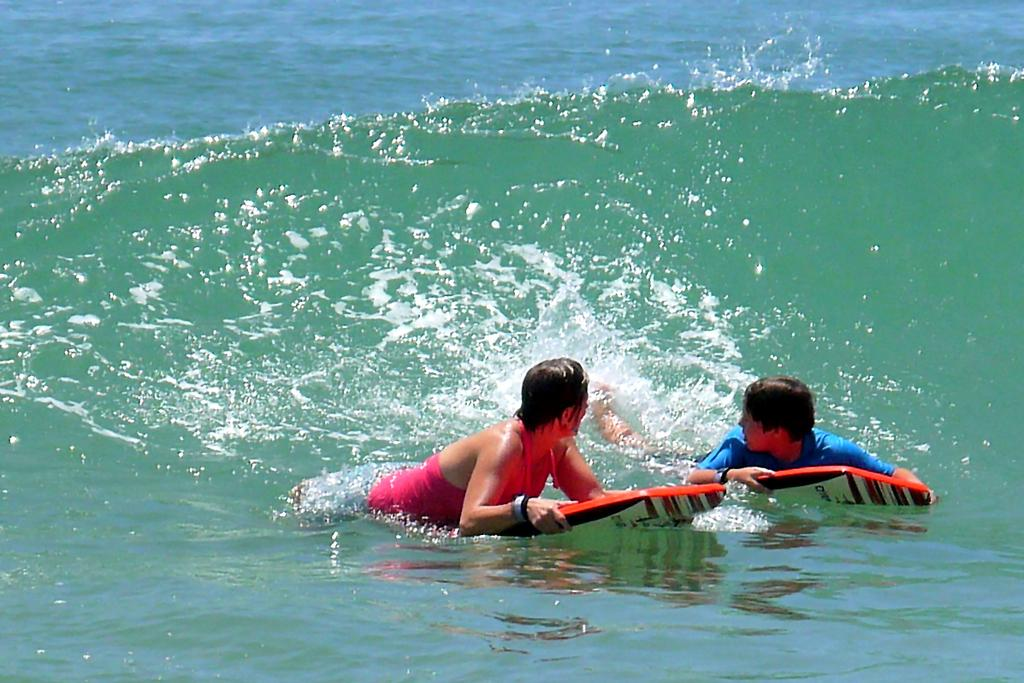How many people are in the image? There are two persons in the image. What are the persons doing in the image? The persons are on surfboards. What is the primary setting or environment in the image? There is water visible in the image. What type of silk fabric is being used by the persons in the image? There is no silk fabric present in the image; the persons are on surfboards in water. 